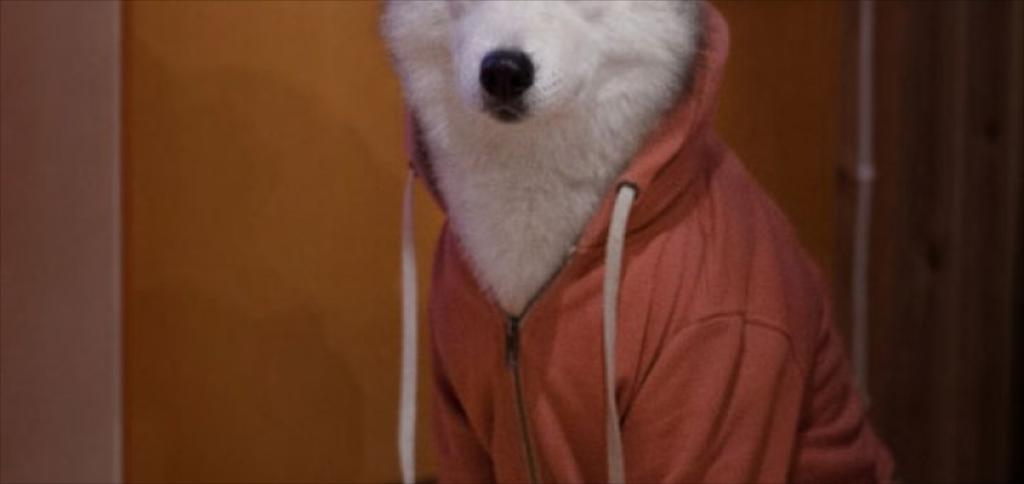What type of animal is present in the image? There is a white-colored animal in the image. What is unique about the appearance of the animal? The animal is wearing clothes. What can be seen in the background of the image? There is a wall in the background of the image. How many trucks are parked next to the animal in the image? There are no trucks present in the image. What type of cracker is the animal holding in the image? The animal is not holding any cracker in the image. 